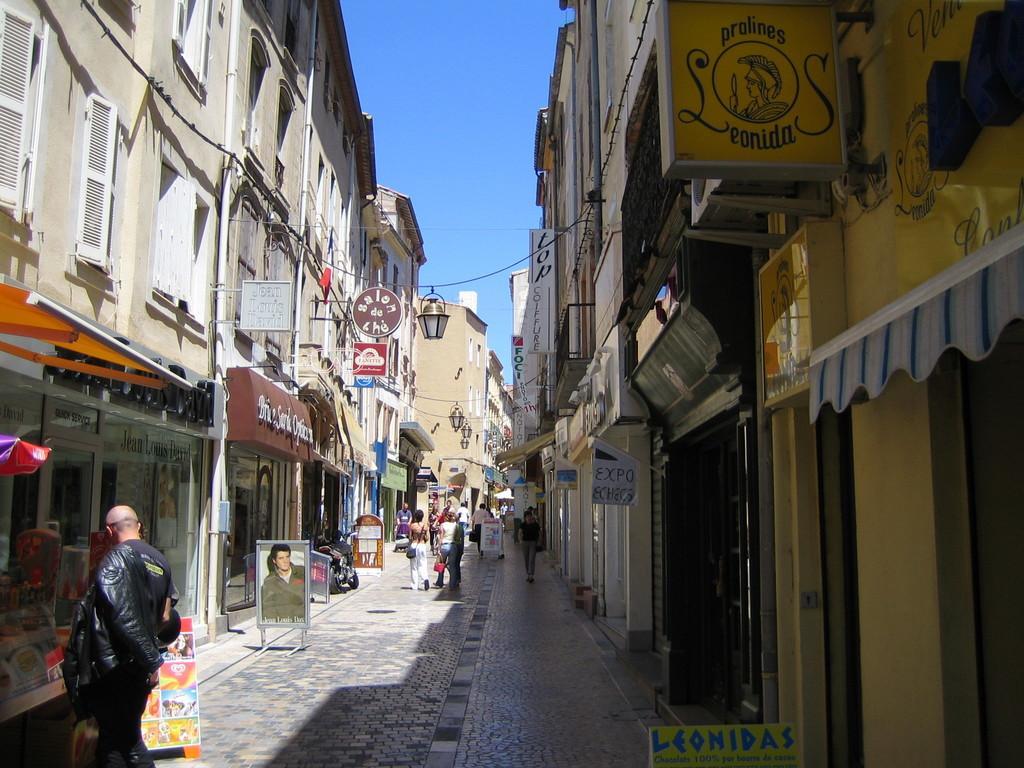Can you describe this image briefly? In the foreground of this image, on the path there are people walking and standing and we can also see boards. On either side, there are buildings, boards and in the middle, there are lamps hanging. At the top, there is the sky. 